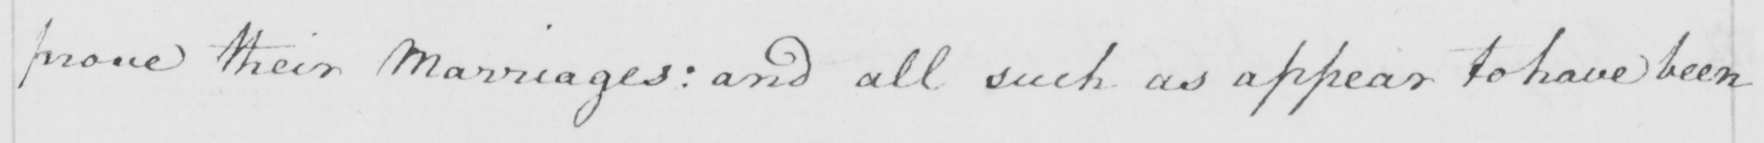Can you tell me what this handwritten text says? prove their Marriages :  and all such as appear to have been 